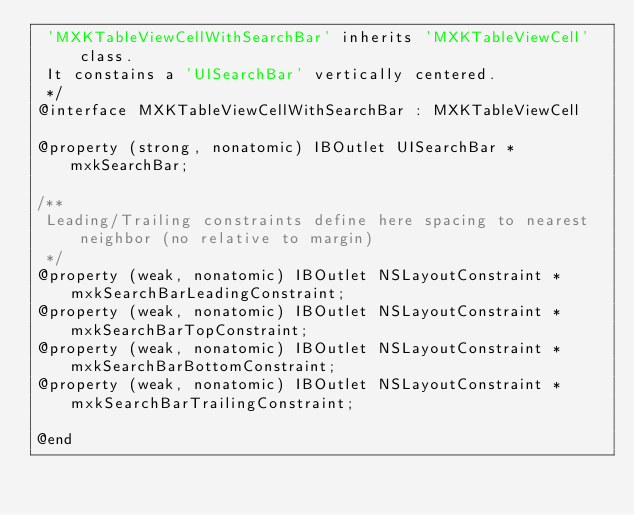Convert code to text. <code><loc_0><loc_0><loc_500><loc_500><_C_> 'MXKTableViewCellWithSearchBar' inherits 'MXKTableViewCell' class.
 It constains a 'UISearchBar' vertically centered.
 */
@interface MXKTableViewCellWithSearchBar : MXKTableViewCell

@property (strong, nonatomic) IBOutlet UISearchBar *mxkSearchBar;

/**
 Leading/Trailing constraints define here spacing to nearest neighbor (no relative to margin)
 */
@property (weak, nonatomic) IBOutlet NSLayoutConstraint *mxkSearchBarLeadingConstraint;
@property (weak, nonatomic) IBOutlet NSLayoutConstraint *mxkSearchBarTopConstraint;
@property (weak, nonatomic) IBOutlet NSLayoutConstraint *mxkSearchBarBottomConstraint;
@property (weak, nonatomic) IBOutlet NSLayoutConstraint *mxkSearchBarTrailingConstraint;

@end</code> 